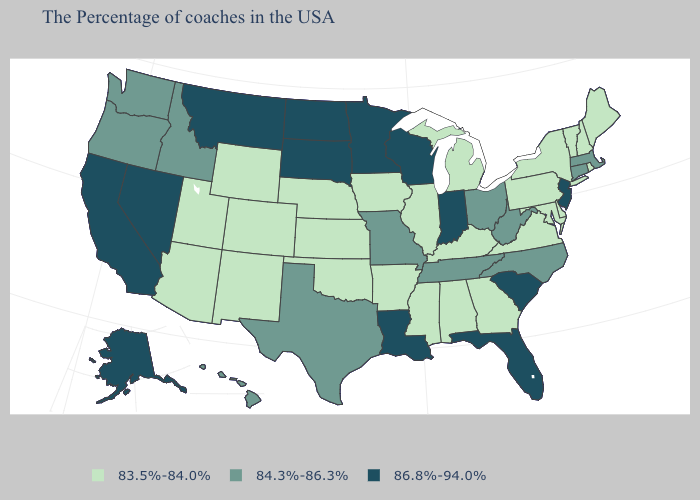Which states have the lowest value in the Northeast?
Keep it brief. Maine, Rhode Island, New Hampshire, Vermont, New York, Pennsylvania. Name the states that have a value in the range 83.5%-84.0%?
Concise answer only. Maine, Rhode Island, New Hampshire, Vermont, New York, Delaware, Maryland, Pennsylvania, Virginia, Georgia, Michigan, Kentucky, Alabama, Illinois, Mississippi, Arkansas, Iowa, Kansas, Nebraska, Oklahoma, Wyoming, Colorado, New Mexico, Utah, Arizona. Does South Dakota have the highest value in the MidWest?
Give a very brief answer. Yes. Does Minnesota have the highest value in the MidWest?
Short answer required. Yes. Which states have the lowest value in the MidWest?
Be succinct. Michigan, Illinois, Iowa, Kansas, Nebraska. What is the lowest value in the West?
Answer briefly. 83.5%-84.0%. What is the value of North Carolina?
Keep it brief. 84.3%-86.3%. How many symbols are there in the legend?
Quick response, please. 3. What is the value of North Dakota?
Answer briefly. 86.8%-94.0%. Does New Hampshire have the lowest value in the Northeast?
Quick response, please. Yes. Does New Jersey have the highest value in the Northeast?
Answer briefly. Yes. Among the states that border South Dakota , does Iowa have the highest value?
Be succinct. No. Name the states that have a value in the range 83.5%-84.0%?
Be succinct. Maine, Rhode Island, New Hampshire, Vermont, New York, Delaware, Maryland, Pennsylvania, Virginia, Georgia, Michigan, Kentucky, Alabama, Illinois, Mississippi, Arkansas, Iowa, Kansas, Nebraska, Oklahoma, Wyoming, Colorado, New Mexico, Utah, Arizona. What is the value of Massachusetts?
Keep it brief. 84.3%-86.3%. Name the states that have a value in the range 86.8%-94.0%?
Concise answer only. New Jersey, South Carolina, Florida, Indiana, Wisconsin, Louisiana, Minnesota, South Dakota, North Dakota, Montana, Nevada, California, Alaska. 